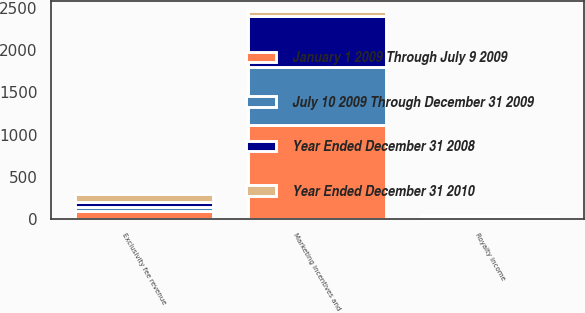Convert chart to OTSL. <chart><loc_0><loc_0><loc_500><loc_500><stacked_bar_chart><ecel><fcel>Marketing incentives and<fcel>Exclusivity fee revenue<fcel>Royalty income<nl><fcel>January 1 2009 Through July 9 2009<fcel>1111<fcel>99<fcel>15<nl><fcel>July 10 2009 Through December 31 2009<fcel>695<fcel>47<fcel>7<nl><fcel>Year Ended December 31 2008<fcel>601<fcel>52<fcel>8<nl><fcel>Year Ended December 31 2010<fcel>52<fcel>105<fcel>16<nl></chart> 